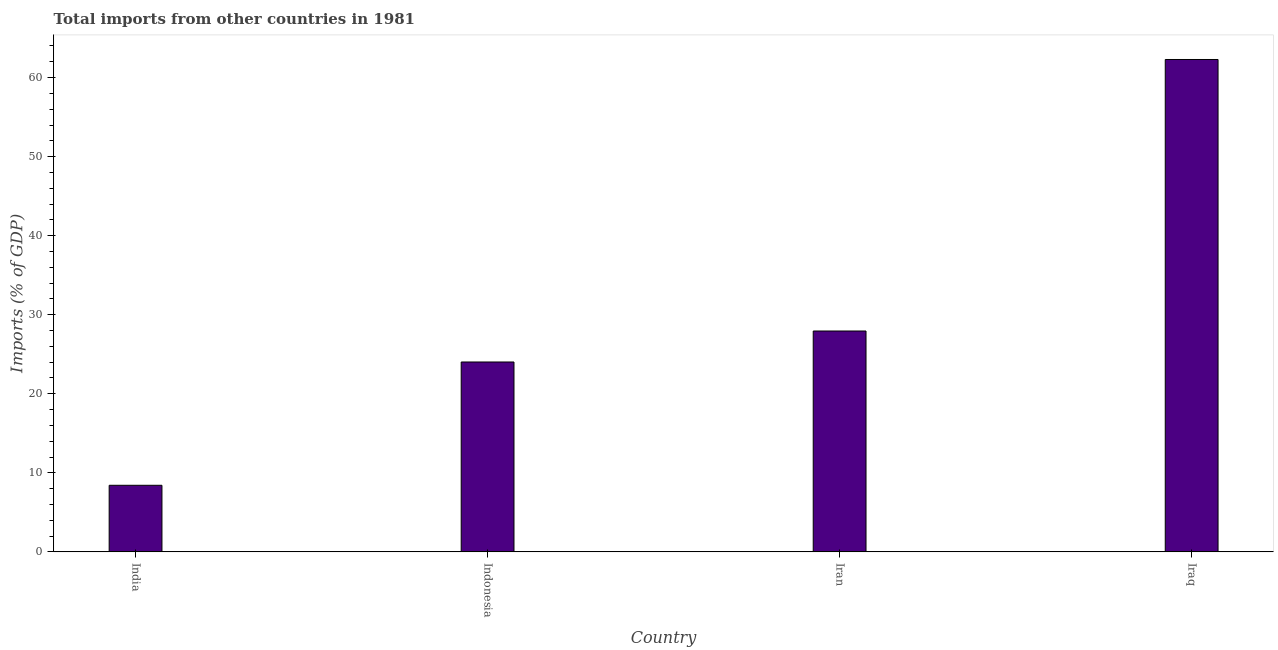What is the title of the graph?
Your response must be concise. Total imports from other countries in 1981. What is the label or title of the X-axis?
Your response must be concise. Country. What is the label or title of the Y-axis?
Your answer should be compact. Imports (% of GDP). What is the total imports in India?
Make the answer very short. 8.42. Across all countries, what is the maximum total imports?
Keep it short and to the point. 62.29. Across all countries, what is the minimum total imports?
Offer a terse response. 8.42. In which country was the total imports maximum?
Keep it short and to the point. Iraq. In which country was the total imports minimum?
Provide a short and direct response. India. What is the sum of the total imports?
Offer a terse response. 122.68. What is the difference between the total imports in India and Iran?
Offer a very short reply. -19.52. What is the average total imports per country?
Make the answer very short. 30.67. What is the median total imports?
Provide a short and direct response. 25.98. In how many countries, is the total imports greater than 52 %?
Ensure brevity in your answer.  1. What is the ratio of the total imports in India to that in Indonesia?
Your answer should be compact. 0.35. What is the difference between the highest and the second highest total imports?
Your response must be concise. 34.35. What is the difference between the highest and the lowest total imports?
Your response must be concise. 53.87. Are all the bars in the graph horizontal?
Give a very brief answer. No. How many countries are there in the graph?
Keep it short and to the point. 4. What is the difference between two consecutive major ticks on the Y-axis?
Keep it short and to the point. 10. Are the values on the major ticks of Y-axis written in scientific E-notation?
Offer a terse response. No. What is the Imports (% of GDP) of India?
Your response must be concise. 8.42. What is the Imports (% of GDP) of Indonesia?
Your response must be concise. 24.02. What is the Imports (% of GDP) in Iran?
Offer a terse response. 27.94. What is the Imports (% of GDP) in Iraq?
Give a very brief answer. 62.29. What is the difference between the Imports (% of GDP) in India and Indonesia?
Your response must be concise. -15.6. What is the difference between the Imports (% of GDP) in India and Iran?
Your answer should be very brief. -19.52. What is the difference between the Imports (% of GDP) in India and Iraq?
Offer a terse response. -53.87. What is the difference between the Imports (% of GDP) in Indonesia and Iran?
Make the answer very short. -3.92. What is the difference between the Imports (% of GDP) in Indonesia and Iraq?
Keep it short and to the point. -38.27. What is the difference between the Imports (% of GDP) in Iran and Iraq?
Your answer should be very brief. -34.35. What is the ratio of the Imports (% of GDP) in India to that in Indonesia?
Your answer should be very brief. 0.35. What is the ratio of the Imports (% of GDP) in India to that in Iran?
Ensure brevity in your answer.  0.3. What is the ratio of the Imports (% of GDP) in India to that in Iraq?
Ensure brevity in your answer.  0.14. What is the ratio of the Imports (% of GDP) in Indonesia to that in Iran?
Your response must be concise. 0.86. What is the ratio of the Imports (% of GDP) in Indonesia to that in Iraq?
Offer a terse response. 0.39. What is the ratio of the Imports (% of GDP) in Iran to that in Iraq?
Offer a very short reply. 0.45. 